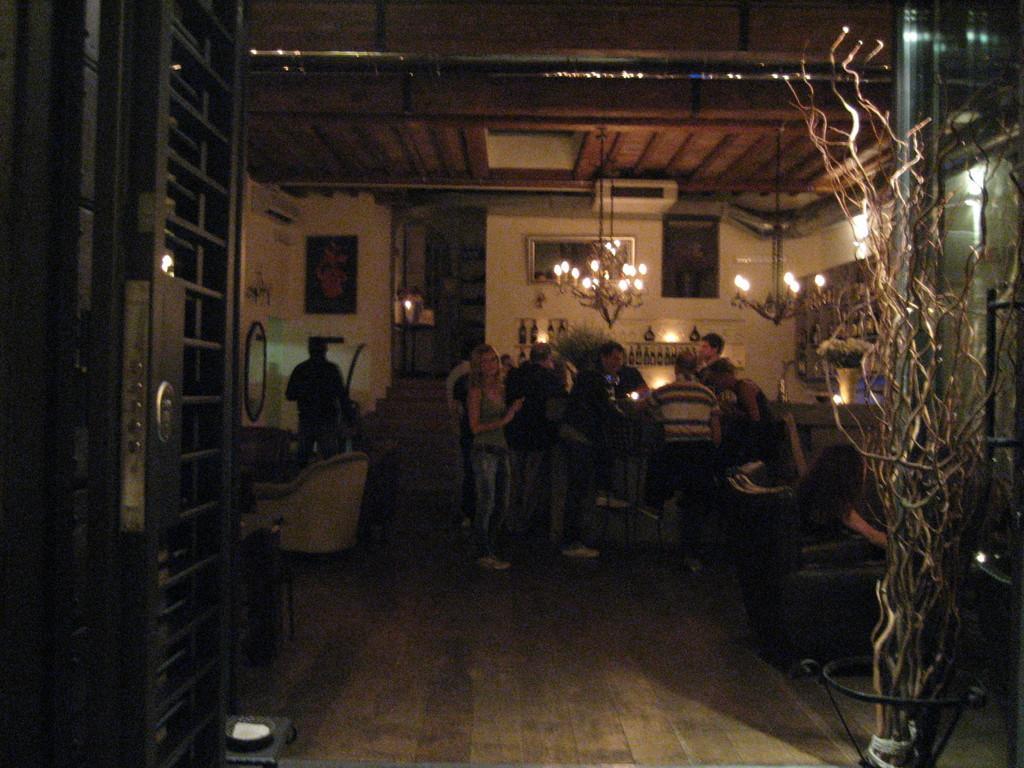How would you summarize this image in a sentence or two? In this image we can see persons, chairs, tables, door, lights and wall. 